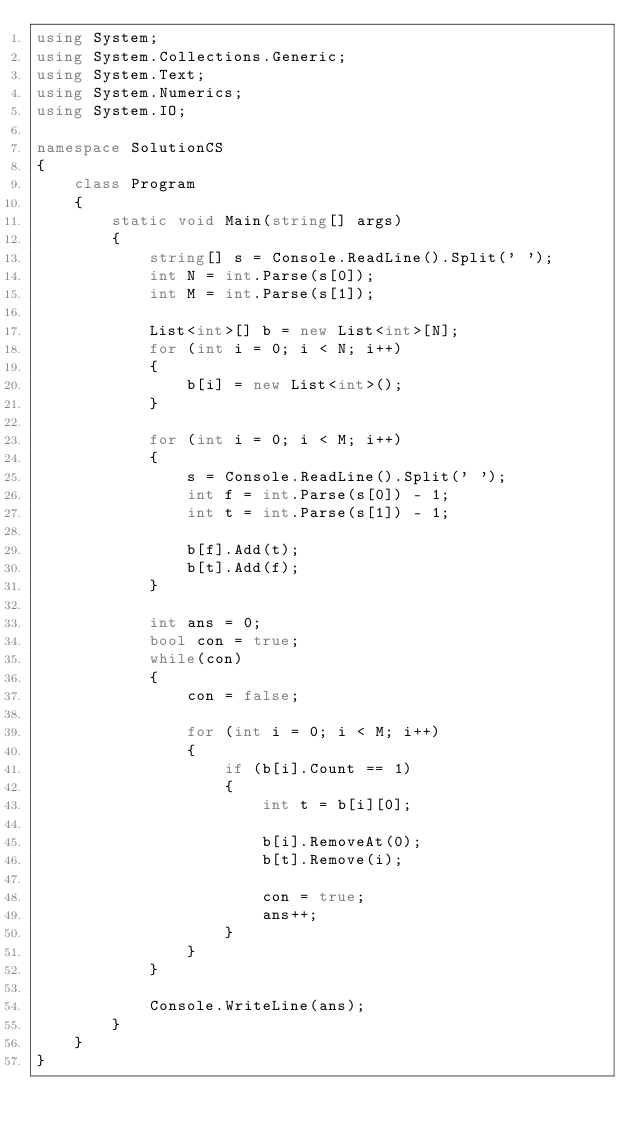<code> <loc_0><loc_0><loc_500><loc_500><_C#_>using System;
using System.Collections.Generic;
using System.Text;
using System.Numerics;
using System.IO;

namespace SolutionCS
{
    class Program
    {
        static void Main(string[] args)
        {
            string[] s = Console.ReadLine().Split(' ');
            int N = int.Parse(s[0]);
            int M = int.Parse(s[1]);

            List<int>[] b = new List<int>[N];
            for (int i = 0; i < N; i++)
            {
                b[i] = new List<int>();
            }

            for (int i = 0; i < M; i++)
            {
                s = Console.ReadLine().Split(' ');
                int f = int.Parse(s[0]) - 1;
                int t = int.Parse(s[1]) - 1;

                b[f].Add(t);
                b[t].Add(f);
            }

            int ans = 0;
            bool con = true;
            while(con)
            {
                con = false;

                for (int i = 0; i < M; i++)
                {
                    if (b[i].Count == 1)
                    {
                        int t = b[i][0];

                        b[i].RemoveAt(0);
                        b[t].Remove(i);

                        con = true;
                        ans++;
                    }
                }
            }

            Console.WriteLine(ans);
        }
    }
}
</code> 